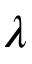<formula> <loc_0><loc_0><loc_500><loc_500>\lambda</formula> 